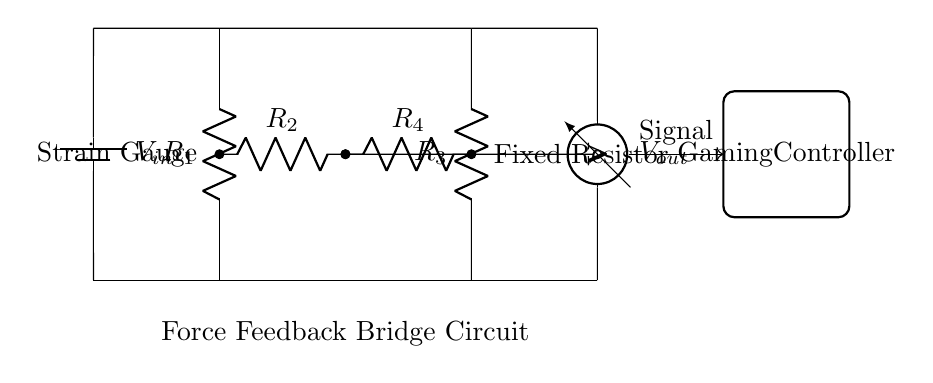What type of resistors are used in this circuit? The circuit diagram shows two types of resistors: resistors labeled as R1 and R3 are fixed resistors, while R2 and R4 are associated with the strain gauges.
Answer: Fixed and Strain Gauge What is the function of the voltage source in this bridge circuit? The voltage source, labeled as V in, provides the necessary power to the circuit to create a potential difference across the resistors, enabling the measurement of strain.
Answer: Power supply How many resistors are present in this bridge circuit? The diagram depicts four resistors: R1, R2, R3, and R4, which are essential for forming the bridge configuration.
Answer: Four What is the output of the circuit, and how is it measured? The output, labeled as V out, is the voltage measured between the midpoints of R2 and R4. It indicates the amount of strain detected by the gauge.
Answer: Voltage What happens to the output voltage if the strain gauge experiences an increase in force? An increase in force applied to the strain gauge leads to an increase in the resistance of the gauge, resulting in an imbalance in the bridge and a change in the output voltage.
Answer: Output increases Which components are located in the middle of the bridge configuration? The middle components of the bridge circuit are R2 and R4, which connect the two halves of the bridge and are essential for detecting differences in resistance caused by strain.
Answer: R2 and R4 What is the primary application of this strain gauge bridge circuit? The primary application of this circuit is to provide force feedback in gaming peripherals, allowing users to experience tactile sensations that simulate real-world interactions.
Answer: Gaming peripherals 